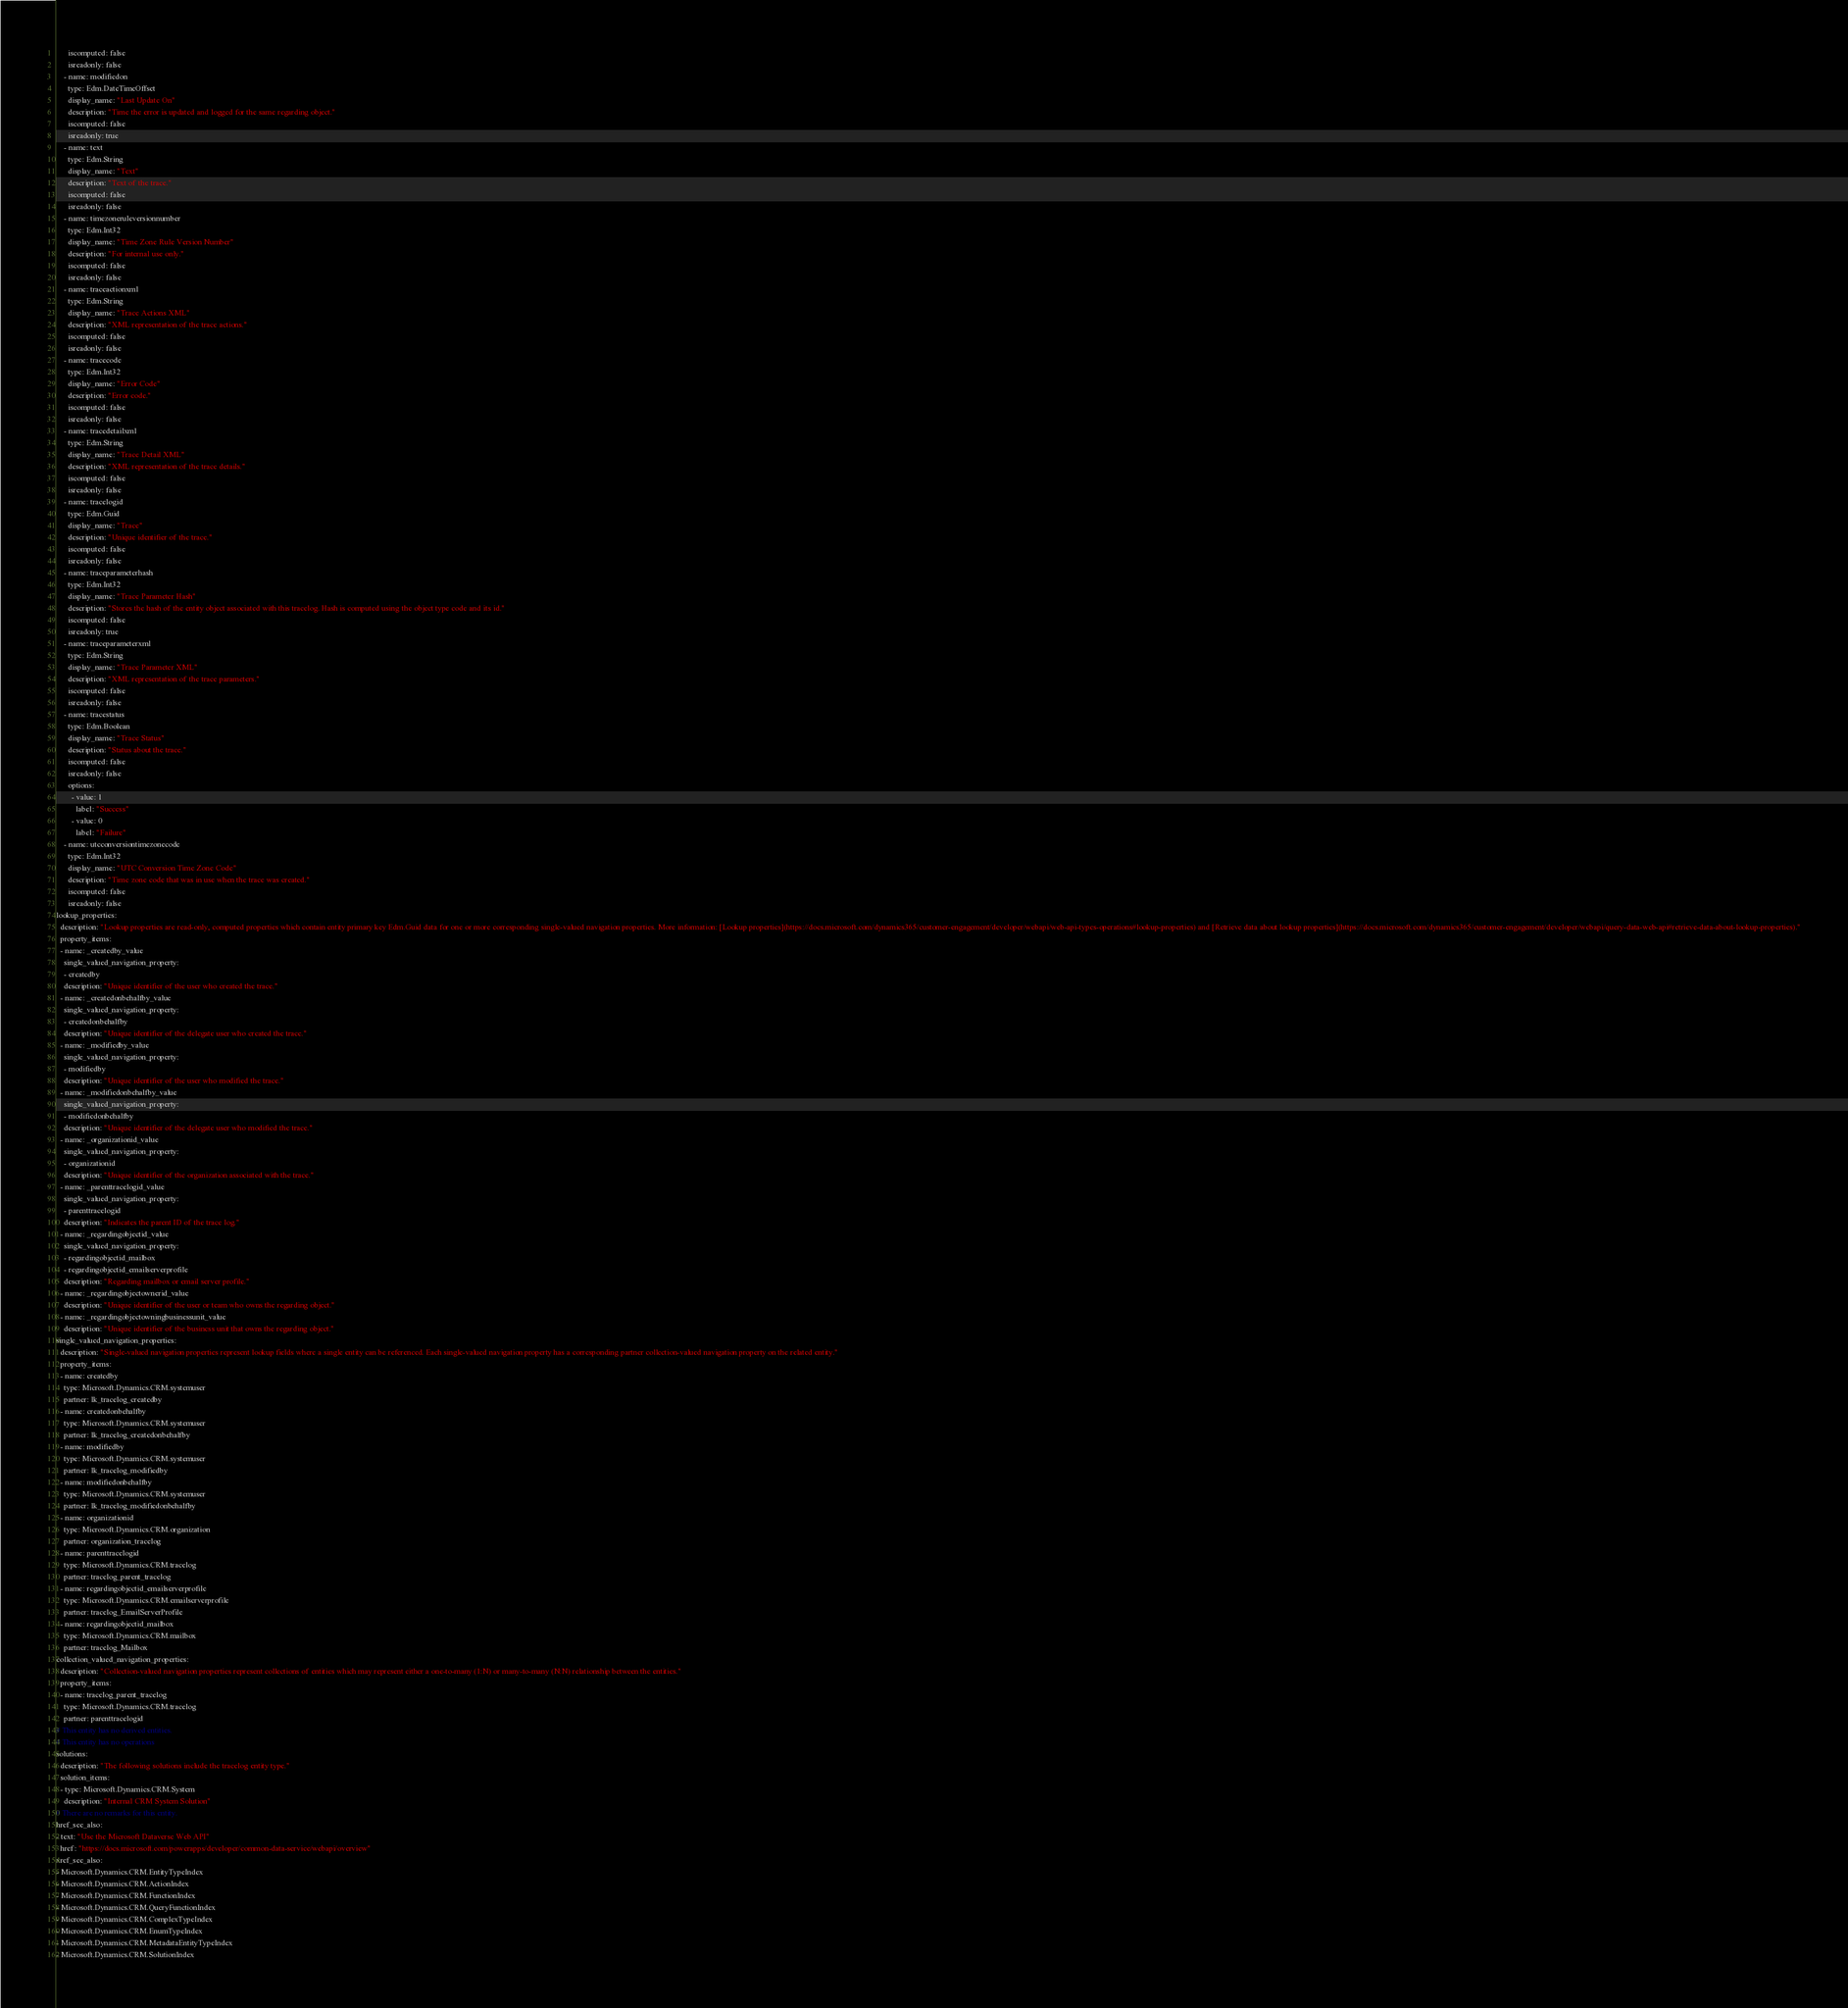Convert code to text. <code><loc_0><loc_0><loc_500><loc_500><_YAML_>      iscomputed: false
      isreadonly: false
    - name: modifiedon
      type: Edm.DateTimeOffset
      display_name: "Last Update On"
      description: "Time the error is updated and logged for the same regarding object."
      iscomputed: false
      isreadonly: true
    - name: text
      type: Edm.String
      display_name: "Text"
      description: "Text of the trace."
      iscomputed: false
      isreadonly: false
    - name: timezoneruleversionnumber
      type: Edm.Int32
      display_name: "Time Zone Rule Version Number"
      description: "For internal use only."
      iscomputed: false
      isreadonly: false
    - name: traceactionxml
      type: Edm.String
      display_name: "Trace Actions XML"
      description: "XML representation of the trace actions."
      iscomputed: false
      isreadonly: false
    - name: tracecode
      type: Edm.Int32
      display_name: "Error Code"
      description: "Error code."
      iscomputed: false
      isreadonly: false
    - name: tracedetailxml
      type: Edm.String
      display_name: "Trace Detail XML"
      description: "XML representation of the trace details."
      iscomputed: false
      isreadonly: false
    - name: tracelogid
      type: Edm.Guid
      display_name: "Trace"
      description: "Unique identifier of the trace."
      iscomputed: false
      isreadonly: false
    - name: traceparameterhash
      type: Edm.Int32
      display_name: "Trace Parameter Hash"
      description: "Stores the hash of the entity object associated with this tracelog. Hash is computed using the object type code and its id."
      iscomputed: false
      isreadonly: true
    - name: traceparameterxml
      type: Edm.String
      display_name: "Trace Parameter XML"
      description: "XML representation of the trace parameters."
      iscomputed: false
      isreadonly: false
    - name: tracestatus
      type: Edm.Boolean
      display_name: "Trace Status"
      description: "Status about the trace."
      iscomputed: false
      isreadonly: false
      options:
        - value: 1
          label: "Success"
        - value: 0
          label: "Failure"
    - name: utcconversiontimezonecode
      type: Edm.Int32
      display_name: "UTC Conversion Time Zone Code"
      description: "Time zone code that was in use when the trace was created."
      iscomputed: false
      isreadonly: false
lookup_properties:
  description: "Lookup properties are read-only, computed properties which contain entity primary key Edm.Guid data for one or more corresponding single-valued navigation properties. More information: [Lookup properties](https://docs.microsoft.com/dynamics365/customer-engagement/developer/webapi/web-api-types-operations#lookup-properties) and [Retrieve data about lookup properties](https://docs.microsoft.com/dynamics365/customer-engagement/developer/webapi/query-data-web-api#retrieve-data-about-lookup-properties)."
  property_items:
  - name: _createdby_value
    single_valued_navigation_property:
    - createdby
    description: "Unique identifier of the user who created the trace."
  - name: _createdonbehalfby_value
    single_valued_navigation_property:
    - createdonbehalfby
    description: "Unique identifier of the delegate user who created the trace."
  - name: _modifiedby_value
    single_valued_navigation_property:
    - modifiedby
    description: "Unique identifier of the user who modified the trace."
  - name: _modifiedonbehalfby_value
    single_valued_navigation_property:
    - modifiedonbehalfby
    description: "Unique identifier of the delegate user who modified the trace."
  - name: _organizationid_value
    single_valued_navigation_property:
    - organizationid
    description: "Unique identifier of the organization associated with the trace."
  - name: _parenttracelogid_value
    single_valued_navigation_property:
    - parenttracelogid
    description: "Indicates the parent ID of the trace log."
  - name: _regardingobjectid_value
    single_valued_navigation_property:
    - regardingobjectid_mailbox
    - regardingobjectid_emailserverprofile
    description: "Regarding mailbox or email server profile."
  - name: _regardingobjectownerid_value
    description: "Unique identifier of the user or team who owns the regarding object."
  - name: _regardingobjectowningbusinessunit_value
    description: "Unique identifier of the business unit that owns the regarding object."
single_valued_navigation_properties:
  description: "Single-valued navigation properties represent lookup fields where a single entity can be referenced. Each single-valued navigation property has a corresponding partner collection-valued navigation property on the related entity."
  property_items:
  - name: createdby
    type: Microsoft.Dynamics.CRM.systemuser
    partner: lk_tracelog_createdby
  - name: createdonbehalfby
    type: Microsoft.Dynamics.CRM.systemuser
    partner: lk_tracelog_createdonbehalfby
  - name: modifiedby
    type: Microsoft.Dynamics.CRM.systemuser
    partner: lk_tracelog_modifiedby
  - name: modifiedonbehalfby
    type: Microsoft.Dynamics.CRM.systemuser
    partner: lk_tracelog_modifiedonbehalfby
  - name: organizationid
    type: Microsoft.Dynamics.CRM.organization
    partner: organization_tracelog
  - name: parenttracelogid
    type: Microsoft.Dynamics.CRM.tracelog
    partner: tracelog_parent_tracelog
  - name: regardingobjectid_emailserverprofile
    type: Microsoft.Dynamics.CRM.emailserverprofile
    partner: tracelog_EmailServerProfile
  - name: regardingobjectid_mailbox
    type: Microsoft.Dynamics.CRM.mailbox
    partner: tracelog_Mailbox
collection_valued_navigation_properties:
  description: "Collection-valued navigation properties represent collections of entities which may represent either a one-to-many (1:N) or many-to-many (N:N) relationship between the entities."
  property_items:
  - name: tracelog_parent_tracelog
    type: Microsoft.Dynamics.CRM.tracelog
    partner: parenttracelogid
# This entity has no derived entities.
# This entity has no operations
solutions:
  description: "The following solutions include the tracelog entity type."
  solution_items:
  - type: Microsoft.Dynamics.CRM.System
    description: "Internal CRM System Solution"
# There are no remarks for this entity.
href_see_also:
- text: "Use the Microsoft Dataverse Web API"
  href: "https://docs.microsoft.com/powerapps/developer/common-data-service/webapi/overview"
xref_see_also:
- Microsoft.Dynamics.CRM.EntityTypeIndex
- Microsoft.Dynamics.CRM.ActionIndex
- Microsoft.Dynamics.CRM.FunctionIndex
- Microsoft.Dynamics.CRM.QueryFunctionIndex
- Microsoft.Dynamics.CRM.ComplexTypeIndex
- Microsoft.Dynamics.CRM.EnumTypeIndex
- Microsoft.Dynamics.CRM.MetadataEntityTypeIndex
- Microsoft.Dynamics.CRM.SolutionIndex</code> 